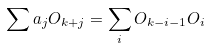Convert formula to latex. <formula><loc_0><loc_0><loc_500><loc_500>\sum a _ { j } O _ { k + j } = \sum _ { i } O _ { k - i - 1 } O _ { i }</formula> 